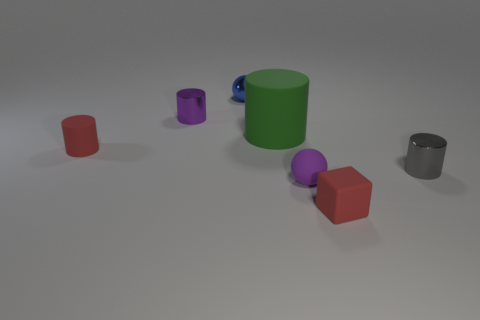Is the number of large cylinders in front of the tiny gray shiny cylinder the same as the number of tiny red matte blocks that are behind the green cylinder?
Make the answer very short. Yes. There is a small red object that is in front of the matte cylinder on the left side of the tiny blue object; how many red matte objects are in front of it?
Make the answer very short. 0. The metallic object that is the same color as the rubber ball is what shape?
Offer a terse response. Cylinder. There is a small rubber sphere; is its color the same as the small shiny cylinder that is left of the green object?
Provide a succinct answer. Yes. Are there more purple shiny cylinders left of the purple sphere than brown rubber things?
Offer a terse response. Yes. What number of things are things that are right of the blue metallic thing or metal objects behind the tiny gray metallic thing?
Your response must be concise. 6. What size is the blue ball that is the same material as the gray object?
Give a very brief answer. Small. Does the purple object that is right of the green thing have the same shape as the blue metallic object?
Your answer should be compact. Yes. There is a object that is the same color as the tiny rubber cylinder; what is its size?
Provide a succinct answer. Small. How many purple things are either tiny rubber cylinders or rubber things?
Make the answer very short. 1. 